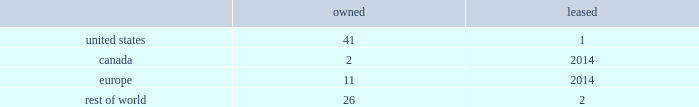While we have remediated the previously-identified material weakness in our internal control over financial reporting , we may identify other material weaknesses in the future .
In november 2017 , we restated our consolidated financial statements for the quarters ended april 1 , 2017 and july 1 , 2017 in order to correctly classify cash receipts from the payments on sold receivables ( which are cash receipts on the underlying trade receivables that have already been securitized ) to cash provided by investing activities ( from cash provided by operating activities ) within our condensed consolidated statements of cash flows .
In connection with these restatements , management identified a material weakness in our internal control over financial reporting related to the misapplication of accounting standards update 2016-15 .
Specifically , we did not maintain effective controls over the adoption of new accounting standards , including communication with the appropriate individuals in coming to our conclusions on the application of new accounting standards .
As a result of this material weakness , our management concluded that we did not maintain effective internal control over financial reporting as of april 1 , 2017 and july 1 , 2017 .
While we have remediated the material weakness and our management has determined that our disclosure controls and procedures were effective as of december 30 , 2017 , there can be no assurance that our controls will remain adequate .
The effectiveness of our internal control over financial reporting is subject to various inherent limitations , including judgments used in decision-making , the nature and complexity of the transactions we undertake , assumptions about the likelihood of future events , the soundness of our systems , cost limitations , and other limitations .
If other material weaknesses or significant deficiencies in our internal control are discovered or occur in the future or we otherwise must restate our financial statements , it could materially and adversely affect our business and results of operations or financial condition , restrict our ability to access the capital markets , require us to expend significant resources to correct the weaknesses or deficiencies , subject us to fines , penalties , investigations or judgments , harm our reputation , or otherwise cause a decline in investor confidence .
Item 1b .
Unresolved staff comments .
Item 2 .
Properties .
Our corporate co-headquarters are located in pittsburgh , pennsylvania and chicago , illinois .
Our co-headquarters are leased and house certain executive offices , our u.s .
Business units , and our administrative , finance , legal , and human resource functions .
We maintain additional owned and leased offices throughout the regions in which we operate .
We manufacture our products in our network of manufacturing and processing facilities located throughout the world .
As of december 30 , 2017 , we operated 83 manufacturing and processing facilities .
We own 80 and lease three of these facilities .
Our manufacturing and processing facilities count by segment as of december 30 , 2017 was: .
We maintain all of our manufacturing and processing facilities in good condition and believe they are suitable and are adequate for our present needs .
We also enter into co-manufacturing arrangements with third parties if we determine it is advantageous to outsource the production of any of our products .
Item 3 .
Legal proceedings .
We are routinely involved in legal proceedings , claims , and governmental inquiries , inspections or investigations ( 201clegal matters 201d ) arising in the ordinary course of our business .
While we cannot predict with certainty the results of legal matters in which we are currently involved or may in the future be involved , we do not expect that the ultimate costs to resolve any of the legal matters that are currently pending will have a material adverse effect on our financial condition or results of operations .
Item 4 .
Mine safety disclosures .
Not applicable. .
What portion of the total facilities is owned by the company? 
Computations: ((((41 + 2) + 11) + 26) / 83)
Answer: 0.96386. 